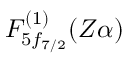Convert formula to latex. <formula><loc_0><loc_0><loc_500><loc_500>F _ { 5 f _ { 7 / 2 } } ^ { ( 1 ) } ( Z \alpha )</formula> 